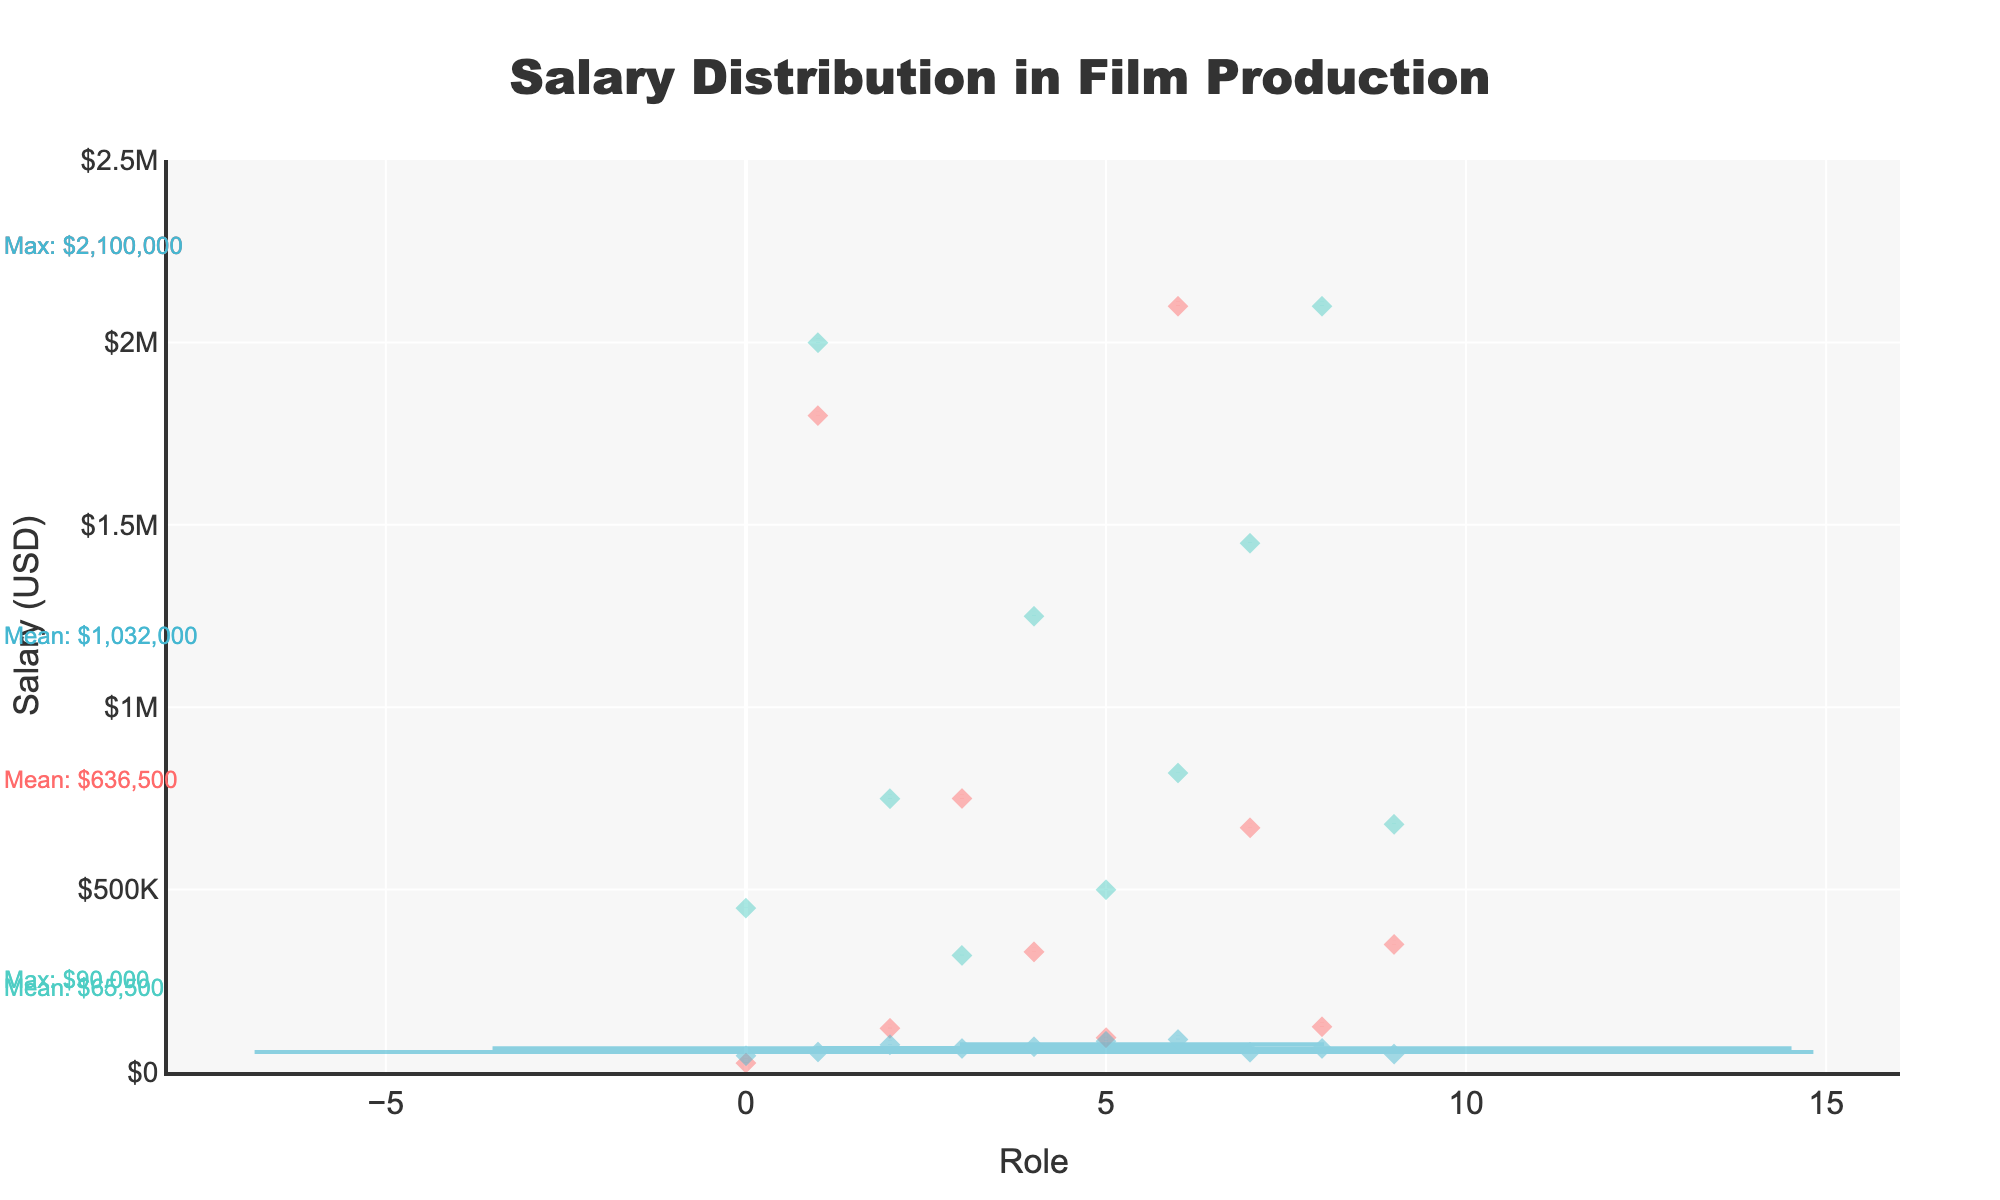What is the title of the figure? The title is typically found at the top of the chart. In this case, the title reads "Salary Distribution in Film Production".
Answer: Salary Distribution in Film Production What is the color used for the Director's salary distribution? The colors used in the plot are mentioned alongside role-specific data points. The Director's salary distribution is marked with the light blue color.
Answer: Light blue What is the mean salary for Actors? The figure includes annotations for statistical values. The mean salary for Actors is marked with an arrow pointing to a note that reads "Mean: $1,067,500".
Answer: $1,067,500 Which role has the highest maximum salary? By comparing annotations indicating maximum salaries, "Max: $2,100,000" is shown for both Actors and Directors. Both these roles share the highest maximum salary.
Answer: Actors and Directors What is the range of salaries for Crew members? The range of salaries can be determined by noting the minimum and maximum values for Crew, which are annotated in the figure. The minimum is $45,000 and the maximum is $90,000.
Answer: $45,000 to $90,000 What role has the largest difference between the minimum and maximum salary? The difference can be calculated by subtracting the minimum salary from the maximum salary for each role. Actors: $2,100,000 - $25,000 = $2,075,000, Directors: $2,100,000 - $320,000 = $1,780,000, Crew: $90,000 - $45,000 = $45,000. Actors have the largest difference.
Answer: Actors How does the median salary of Crew members compare to that of Actors? The median salary, which divides the dataset into two equal halves, can be compared by looking at the annotations. For Crew, it's around $65,000, and for Actors, it's not directly noted but lies around the midpoint of some visible median lines. Overall, Actors have a higher median due to their generally higher range.
Answer: Crew’s median is lower Which role demonstrates the most variability in salaries? Variability can be visually assessed by the spread of the violin plot. The broader and more spread out the plot, the higher the variability. Actors have the most spread-out plot, indicating the highest variability in salaries.
Answer: Actors Is the mean salary greater for Directors or Actors? According to the annotated mean values, Directors have a mean salary of $973,500, and Actors have a mean salary of $1,067,500. Comparing these two, Actors have a higher mean salary.
Answer: Actors What is a unique feature of the violin plot used in this figure? A unique feature of a violin plot, as seen here, is that it shows the full distribution of the data, unlike just box plots; it includes kernel density estimation which gives insight into the probability distribution of the data points.
Answer: Kernel density estimation 